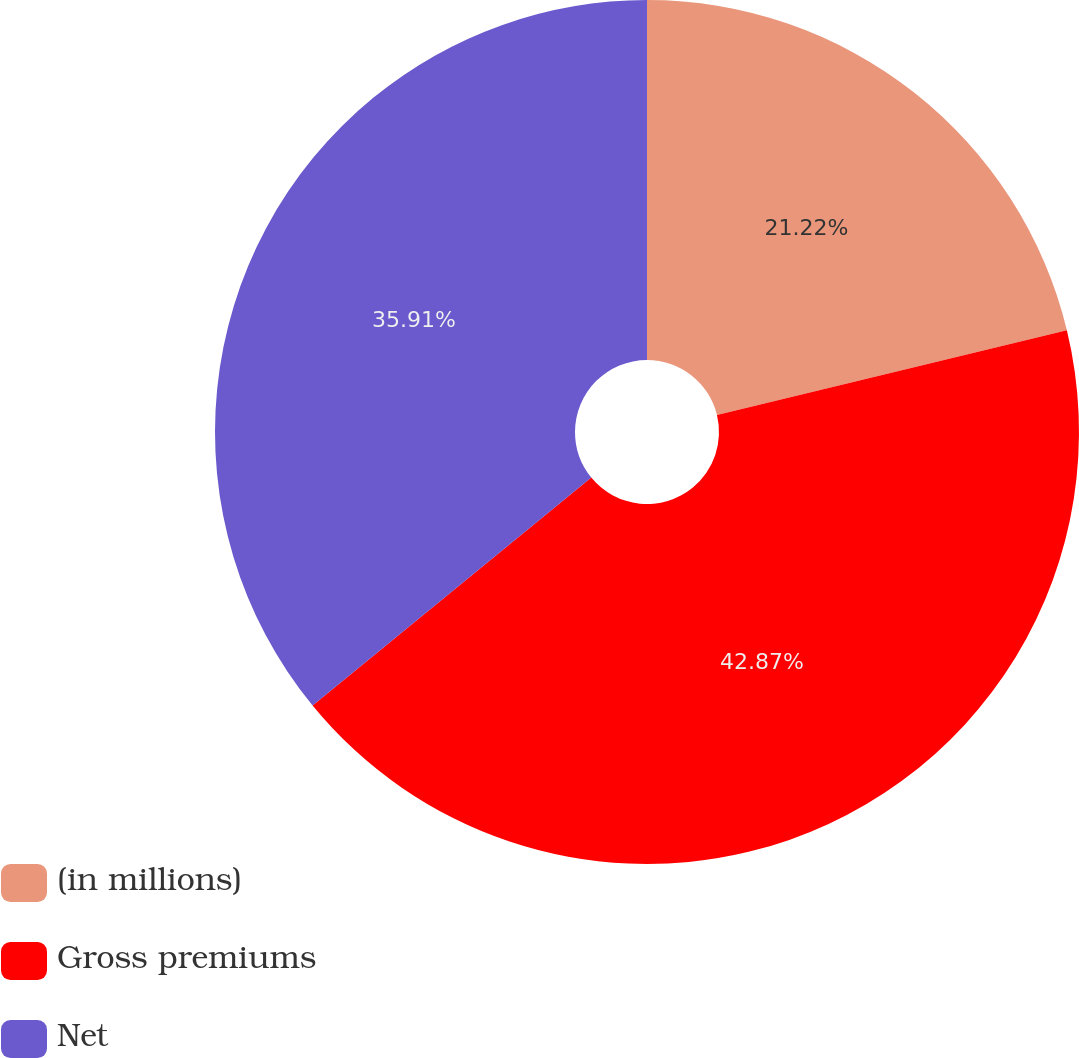Convert chart to OTSL. <chart><loc_0><loc_0><loc_500><loc_500><pie_chart><fcel>(in millions)<fcel>Gross premiums<fcel>Net<nl><fcel>21.22%<fcel>42.87%<fcel>35.91%<nl></chart> 